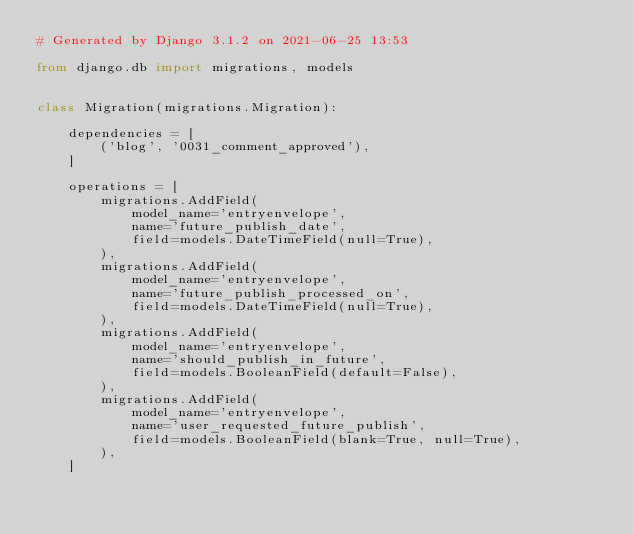Convert code to text. <code><loc_0><loc_0><loc_500><loc_500><_Python_># Generated by Django 3.1.2 on 2021-06-25 13:53

from django.db import migrations, models


class Migration(migrations.Migration):

    dependencies = [
        ('blog', '0031_comment_approved'),
    ]

    operations = [
        migrations.AddField(
            model_name='entryenvelope',
            name='future_publish_date',
            field=models.DateTimeField(null=True),
        ),
        migrations.AddField(
            model_name='entryenvelope',
            name='future_publish_processed_on',
            field=models.DateTimeField(null=True),
        ),
        migrations.AddField(
            model_name='entryenvelope',
            name='should_publish_in_future',
            field=models.BooleanField(default=False),
        ),
        migrations.AddField(
            model_name='entryenvelope',
            name='user_requested_future_publish',
            field=models.BooleanField(blank=True, null=True),
        ),
    ]
</code> 